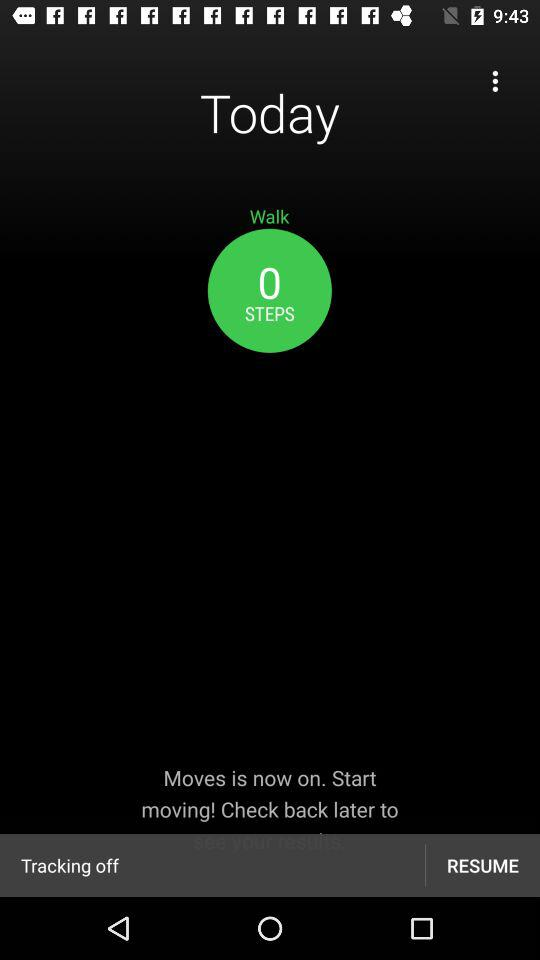How many steps have been taken today? The steps that have been taken today are 0. 